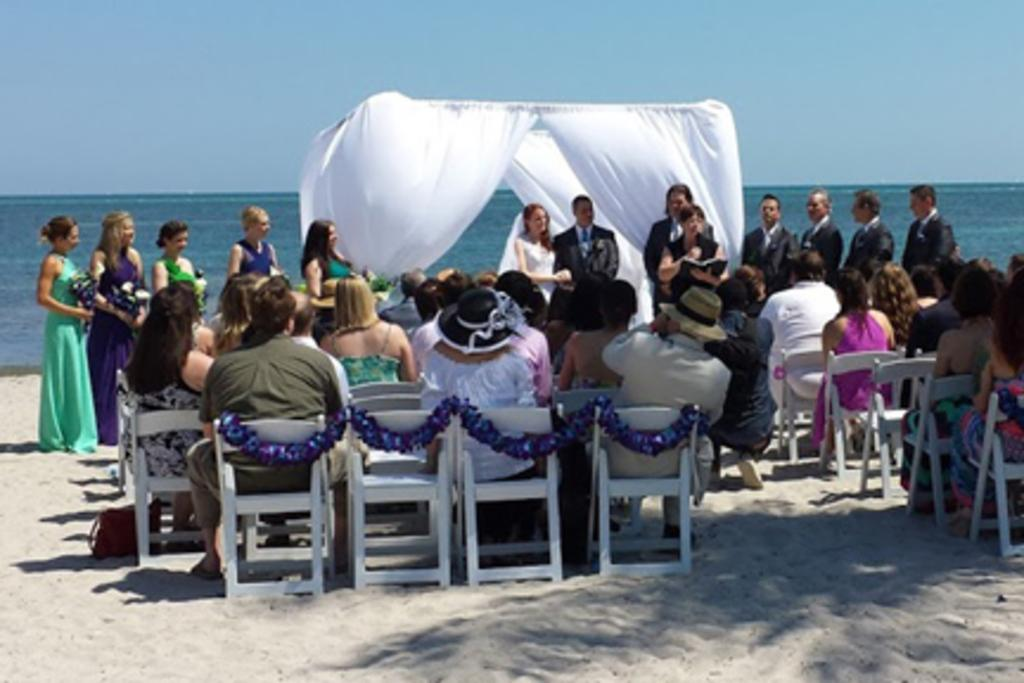What are the people in the image doing? The people in the image are sitting on chairs and standing on a stand. Can you describe the background of the image? There is an ocean visible in the background of the image. What type of structure is present in the image? There is a tent in the image. What type of quill is being used by the people in the image? There is no quill present in the image; the people are not using any writing instruments. What process is being carried out by the people in the image? The image does not depict a specific process; it simply shows people sitting, standing, and a tent in the background. 